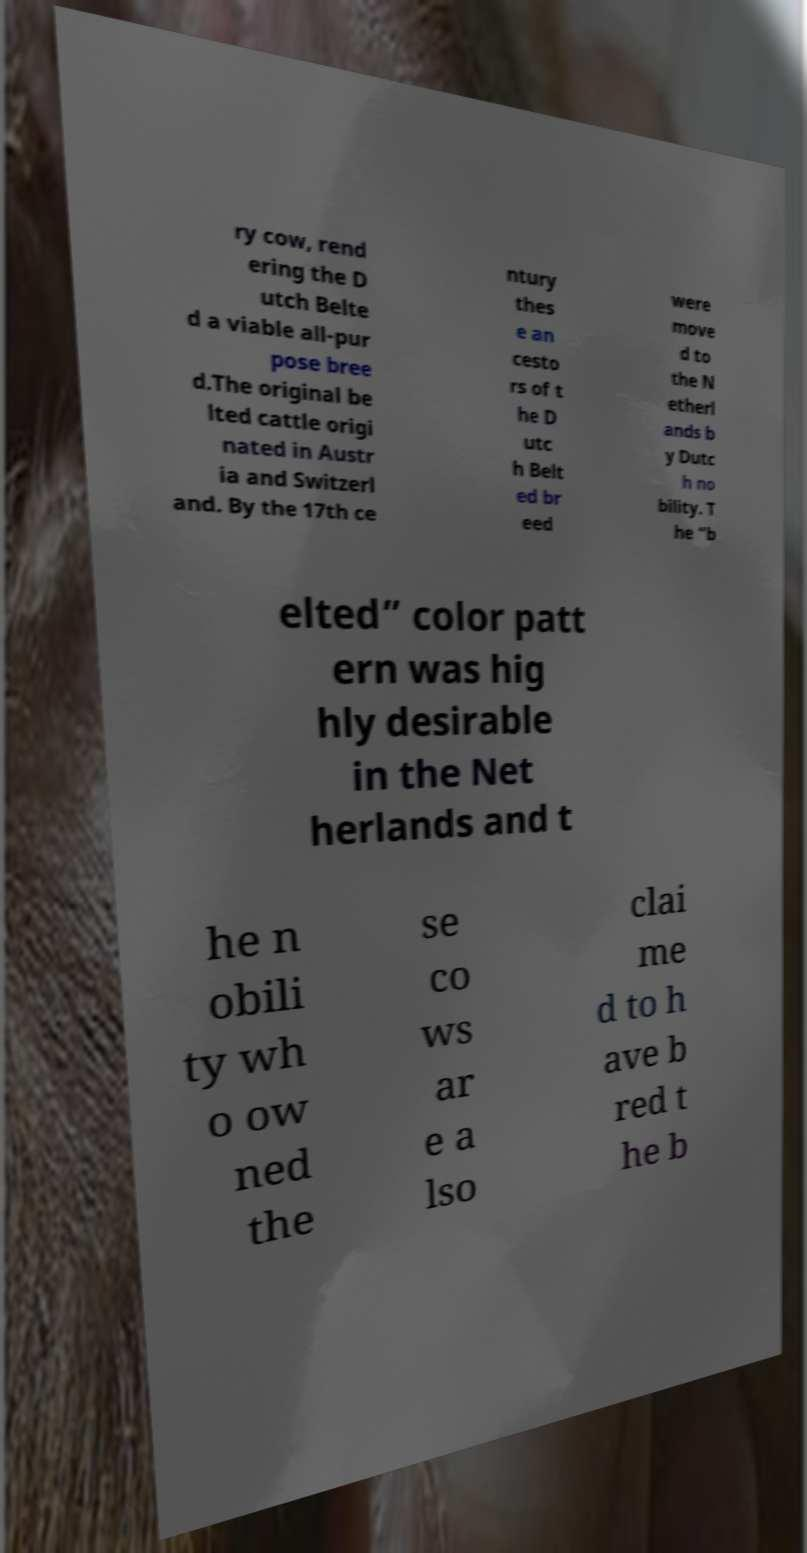I need the written content from this picture converted into text. Can you do that? ry cow, rend ering the D utch Belte d a viable all-pur pose bree d.The original be lted cattle origi nated in Austr ia and Switzerl and. By the 17th ce ntury thes e an cesto rs of t he D utc h Belt ed br eed were move d to the N etherl ands b y Dutc h no bility. T he “b elted” color patt ern was hig hly desirable in the Net herlands and t he n obili ty wh o ow ned the se co ws ar e a lso clai me d to h ave b red t he b 